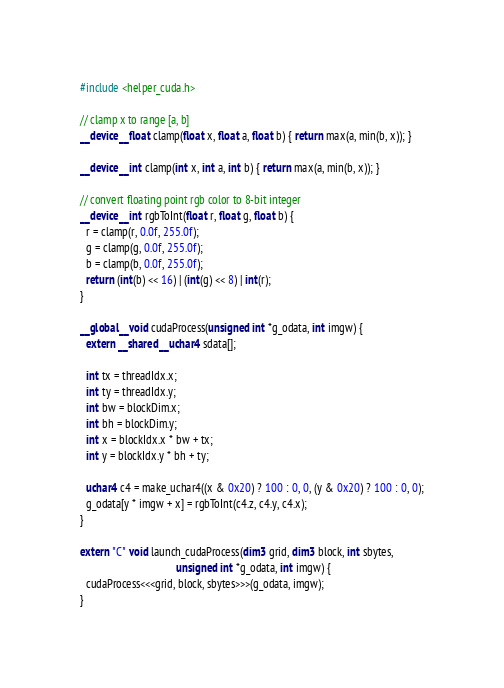Convert code to text. <code><loc_0><loc_0><loc_500><loc_500><_Cuda_>
#include <helper_cuda.h>

// clamp x to range [a, b]
__device__ float clamp(float x, float a, float b) { return max(a, min(b, x)); }

__device__ int clamp(int x, int a, int b) { return max(a, min(b, x)); }

// convert floating point rgb color to 8-bit integer
__device__ int rgbToInt(float r, float g, float b) {
  r = clamp(r, 0.0f, 255.0f);
  g = clamp(g, 0.0f, 255.0f);
  b = clamp(b, 0.0f, 255.0f);
  return (int(b) << 16) | (int(g) << 8) | int(r);
}

__global__ void cudaProcess(unsigned int *g_odata, int imgw) {
  extern __shared__ uchar4 sdata[];

  int tx = threadIdx.x;
  int ty = threadIdx.y;
  int bw = blockDim.x;
  int bh = blockDim.y;
  int x = blockIdx.x * bw + tx;
  int y = blockIdx.y * bh + ty;

  uchar4 c4 = make_uchar4((x & 0x20) ? 100 : 0, 0, (y & 0x20) ? 100 : 0, 0);
  g_odata[y * imgw + x] = rgbToInt(c4.z, c4.y, c4.x);
}

extern "C" void launch_cudaProcess(dim3 grid, dim3 block, int sbytes,
                                   unsigned int *g_odata, int imgw) {
  cudaProcess<<<grid, block, sbytes>>>(g_odata, imgw);
}
</code> 